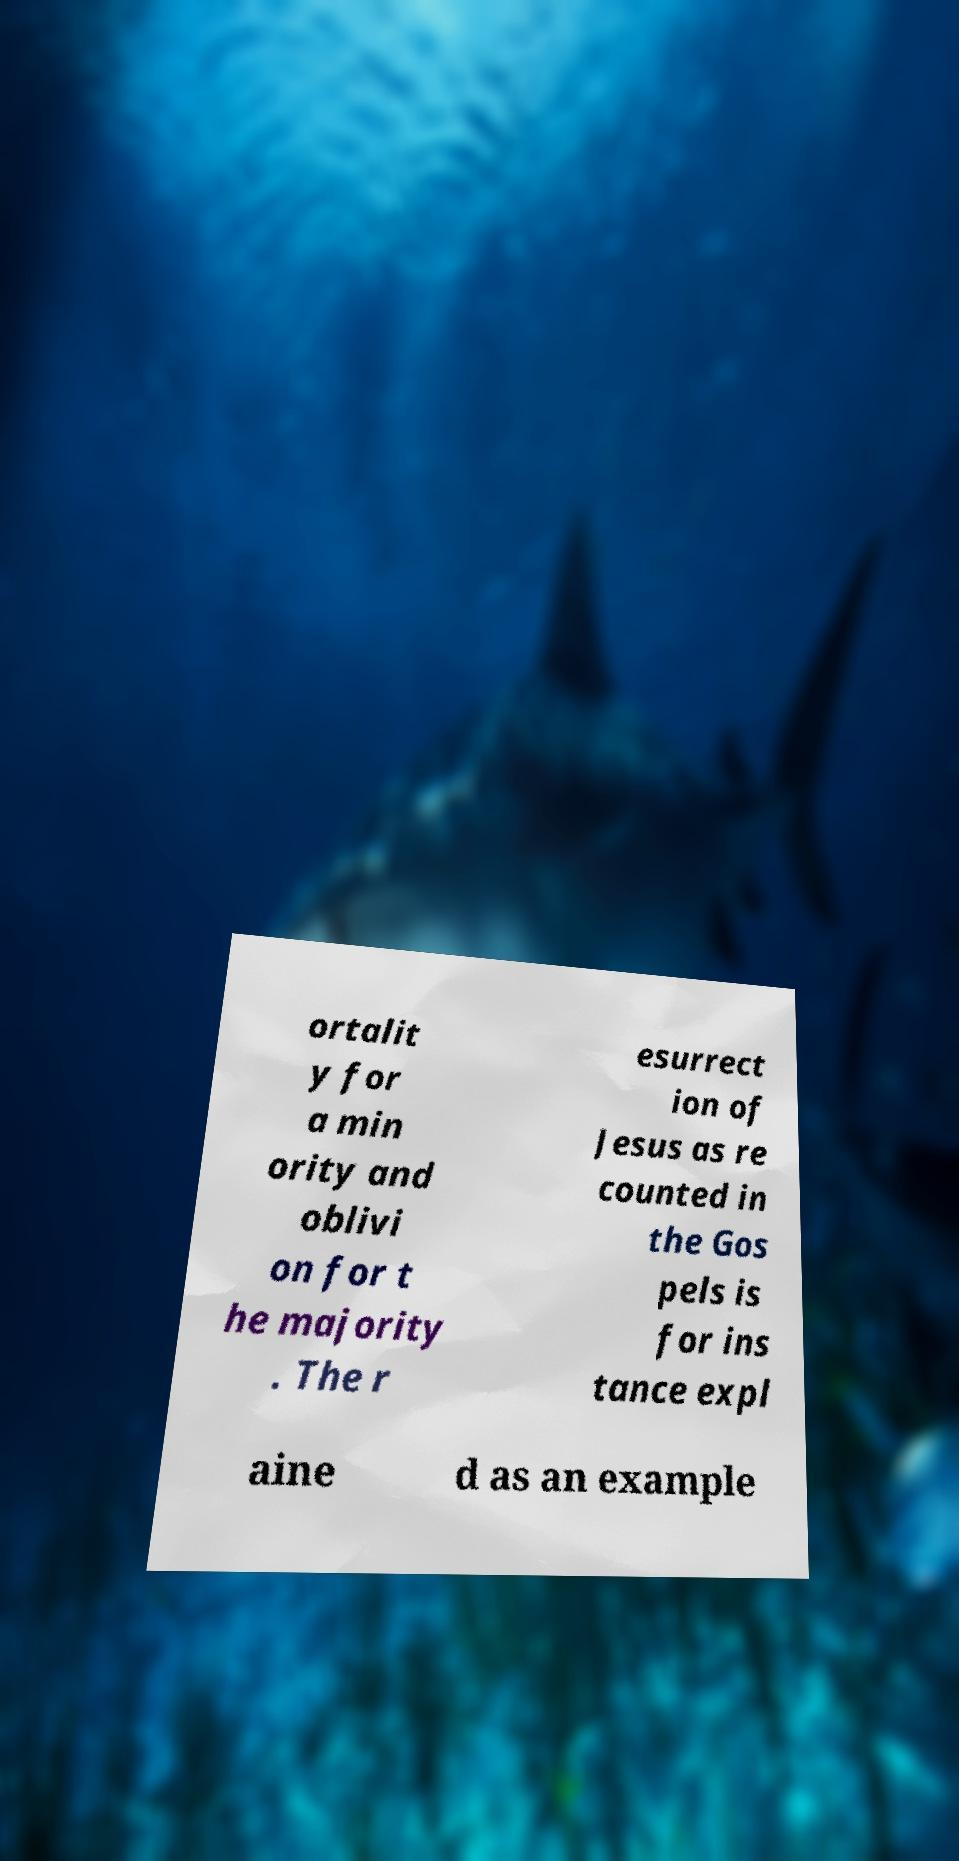What messages or text are displayed in this image? I need them in a readable, typed format. ortalit y for a min ority and oblivi on for t he majority . The r esurrect ion of Jesus as re counted in the Gos pels is for ins tance expl aine d as an example 